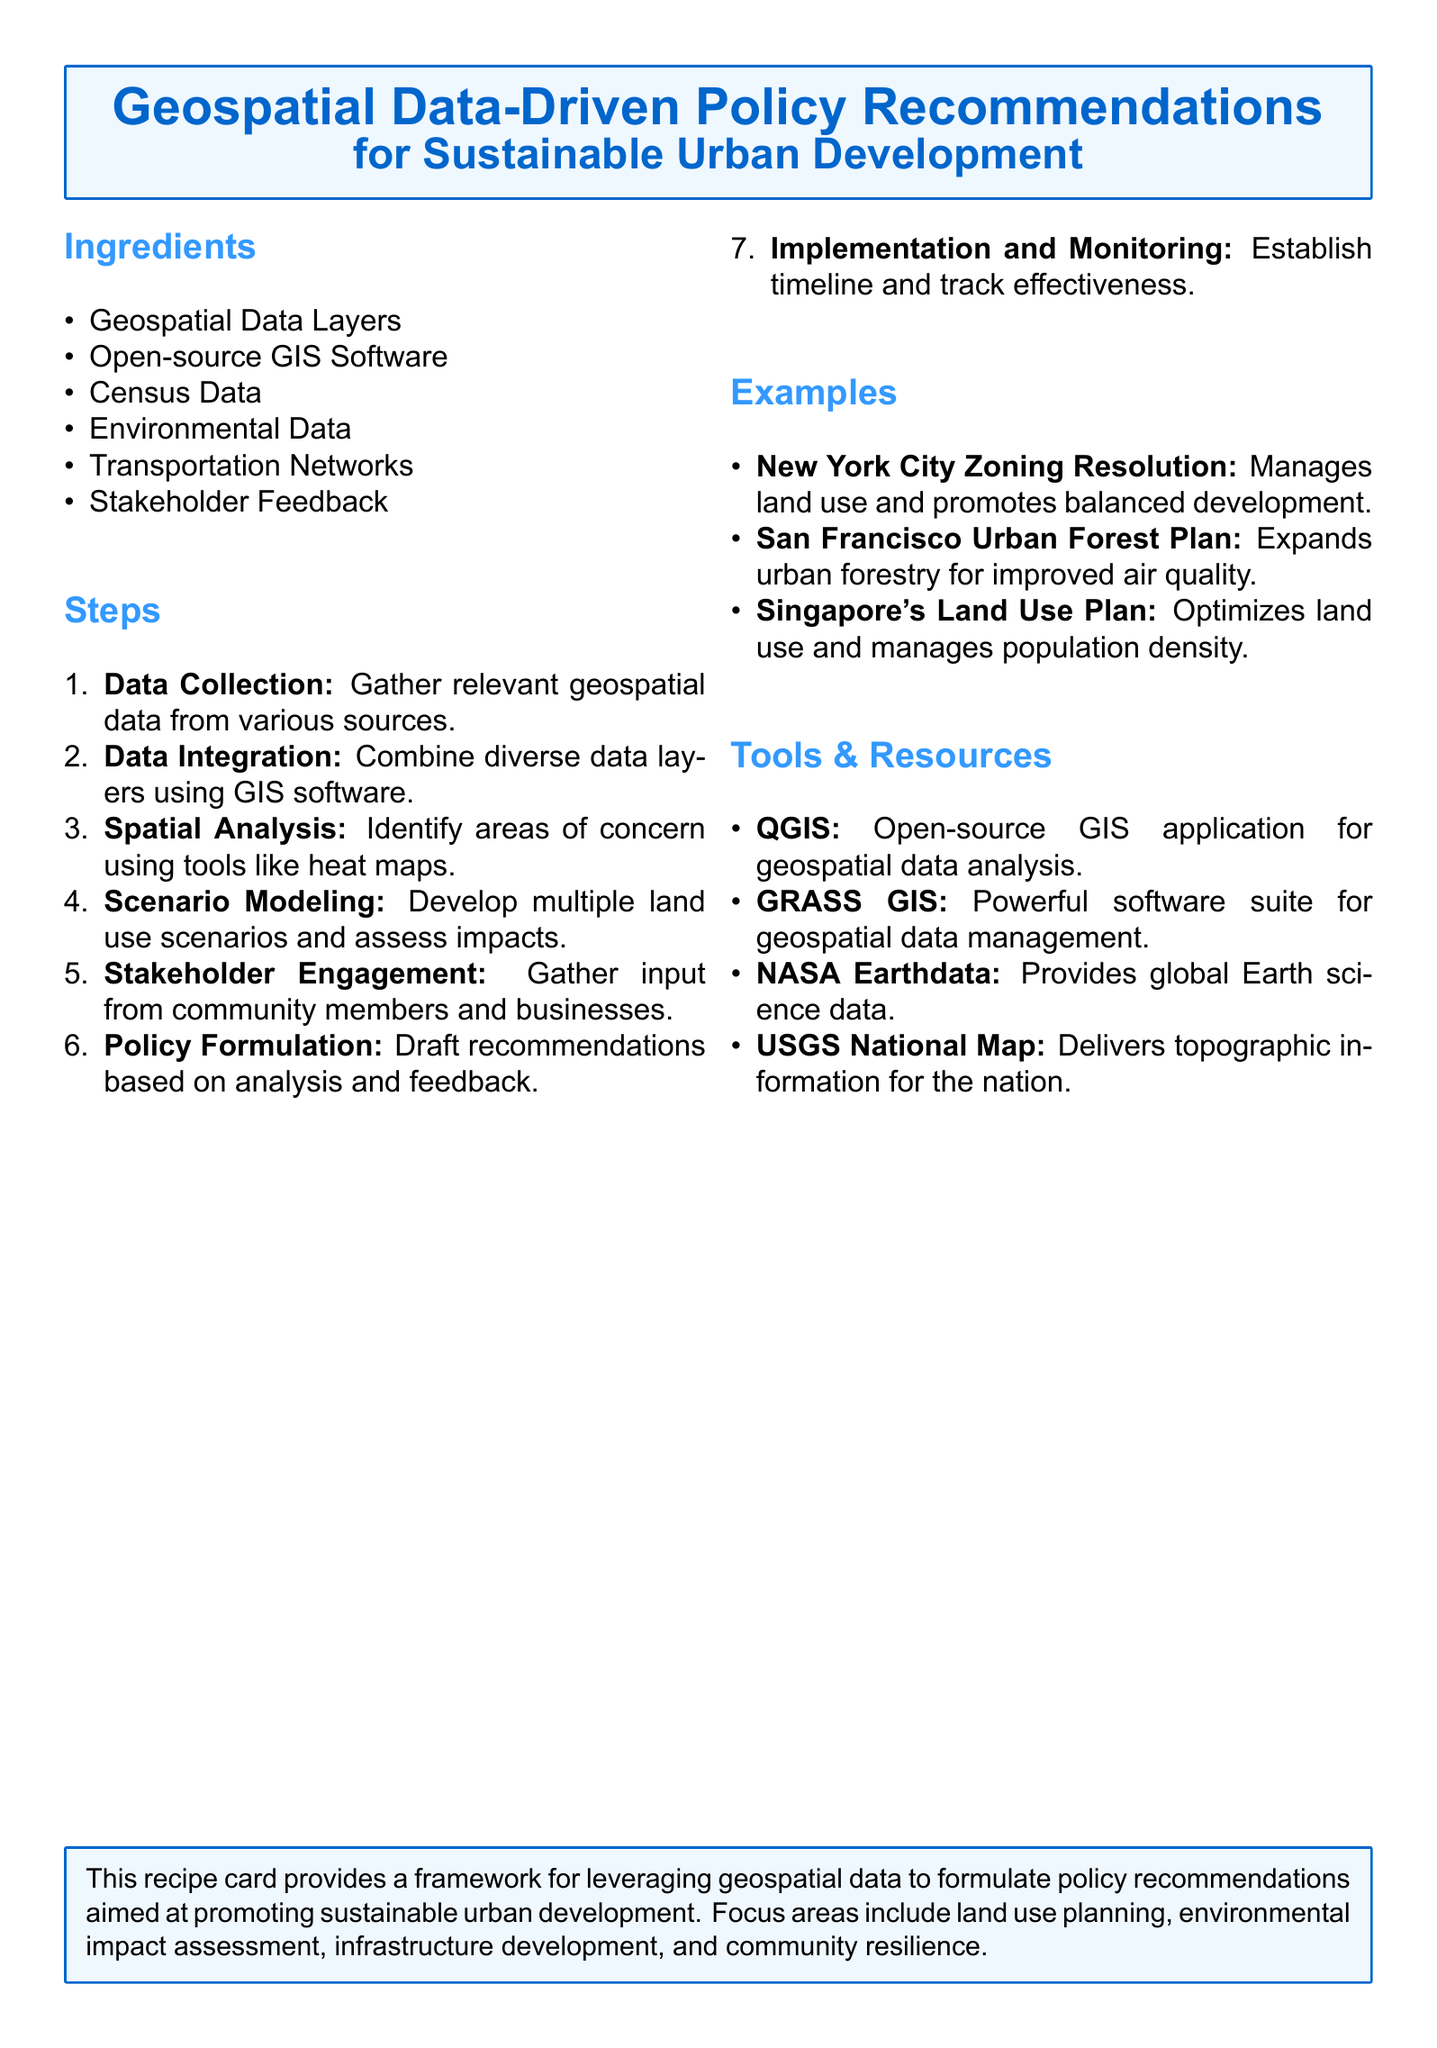What are the main ingredients for the recommendations? The ingredients include various components necessary for the policy recommendations, which are listed in the Ingredients section.
Answer: Geospatial Data Layers, Open-source GIS Software, Census Data, Environmental Data, Transportation Networks, Stakeholder Feedback How many steps are there in the process? The total number of steps involved in the policy recommendation process is counted from the Steps section.
Answer: Seven What is the first step in the process? The first step described in the Steps section is the initial action taken when starting the analysis.
Answer: Data Collection Which software is mentioned as an open-source GIS application? The software specifically identified as an open-source GIS application for analysis is included in the Tools & Resources section.
Answer: QGIS What urban development initiative is associated with New York City? This question asks for a specific example of an urban development initiative listed in the Examples section.
Answer: New York City Zoning Resolution How does stakeholder feedback fit into the policy formulation process? This question looks for the role of stakeholder input in shaping recommendations based on Steps outlined in the document.
Answer: Gather input from community members and businesses What type of data is provided by NASA Earthdata? This question requires an answer related to the type of information available from a specific resource mentioned in the Tools & Resources section.
Answer: Global Earth science data 